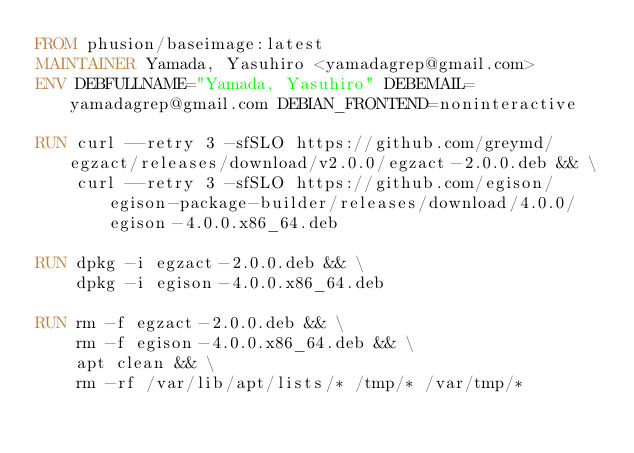<code> <loc_0><loc_0><loc_500><loc_500><_Dockerfile_>FROM phusion/baseimage:latest
MAINTAINER Yamada, Yasuhiro <yamadagrep@gmail.com>
ENV DEBFULLNAME="Yamada, Yasuhiro" DEBEMAIL=yamadagrep@gmail.com DEBIAN_FRONTEND=noninteractive

RUN curl --retry 3 -sfSLO https://github.com/greymd/egzact/releases/download/v2.0.0/egzact-2.0.0.deb && \
    curl --retry 3 -sfSLO https://github.com/egison/egison-package-builder/releases/download/4.0.0/egison-4.0.0.x86_64.deb

RUN dpkg -i egzact-2.0.0.deb && \
    dpkg -i egison-4.0.0.x86_64.deb

RUN rm -f egzact-2.0.0.deb && \
    rm -f egison-4.0.0.x86_64.deb && \
    apt clean && \
    rm -rf /var/lib/apt/lists/* /tmp/* /var/tmp/*
</code> 